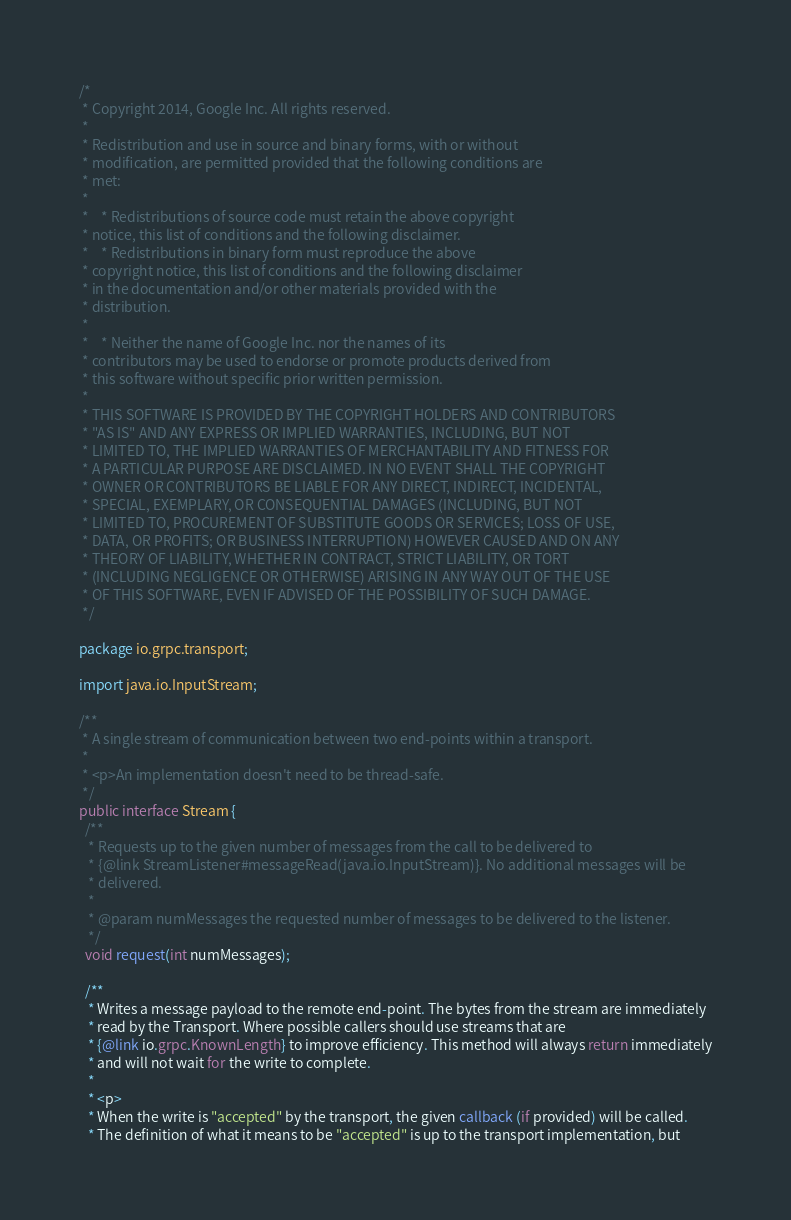Convert code to text. <code><loc_0><loc_0><loc_500><loc_500><_Java_>/*
 * Copyright 2014, Google Inc. All rights reserved.
 *
 * Redistribution and use in source and binary forms, with or without
 * modification, are permitted provided that the following conditions are
 * met:
 *
 *    * Redistributions of source code must retain the above copyright
 * notice, this list of conditions and the following disclaimer.
 *    * Redistributions in binary form must reproduce the above
 * copyright notice, this list of conditions and the following disclaimer
 * in the documentation and/or other materials provided with the
 * distribution.
 *
 *    * Neither the name of Google Inc. nor the names of its
 * contributors may be used to endorse or promote products derived from
 * this software without specific prior written permission.
 *
 * THIS SOFTWARE IS PROVIDED BY THE COPYRIGHT HOLDERS AND CONTRIBUTORS
 * "AS IS" AND ANY EXPRESS OR IMPLIED WARRANTIES, INCLUDING, BUT NOT
 * LIMITED TO, THE IMPLIED WARRANTIES OF MERCHANTABILITY AND FITNESS FOR
 * A PARTICULAR PURPOSE ARE DISCLAIMED. IN NO EVENT SHALL THE COPYRIGHT
 * OWNER OR CONTRIBUTORS BE LIABLE FOR ANY DIRECT, INDIRECT, INCIDENTAL,
 * SPECIAL, EXEMPLARY, OR CONSEQUENTIAL DAMAGES (INCLUDING, BUT NOT
 * LIMITED TO, PROCUREMENT OF SUBSTITUTE GOODS OR SERVICES; LOSS OF USE,
 * DATA, OR PROFITS; OR BUSINESS INTERRUPTION) HOWEVER CAUSED AND ON ANY
 * THEORY OF LIABILITY, WHETHER IN CONTRACT, STRICT LIABILITY, OR TORT
 * (INCLUDING NEGLIGENCE OR OTHERWISE) ARISING IN ANY WAY OUT OF THE USE
 * OF THIS SOFTWARE, EVEN IF ADVISED OF THE POSSIBILITY OF SUCH DAMAGE.
 */

package io.grpc.transport;

import java.io.InputStream;

/**
 * A single stream of communication between two end-points within a transport.
 *
 * <p>An implementation doesn't need to be thread-safe.
 */
public interface Stream {
  /**
   * Requests up to the given number of messages from the call to be delivered to
   * {@link StreamListener#messageRead(java.io.InputStream)}. No additional messages will be
   * delivered.
   *
   * @param numMessages the requested number of messages to be delivered to the listener.
   */
  void request(int numMessages);

  /**
   * Writes a message payload to the remote end-point. The bytes from the stream are immediately
   * read by the Transport. Where possible callers should use streams that are
   * {@link io.grpc.KnownLength} to improve efficiency. This method will always return immediately
   * and will not wait for the write to complete.
   *
   * <p>
   * When the write is "accepted" by the transport, the given callback (if provided) will be called.
   * The definition of what it means to be "accepted" is up to the transport implementation, but</code> 